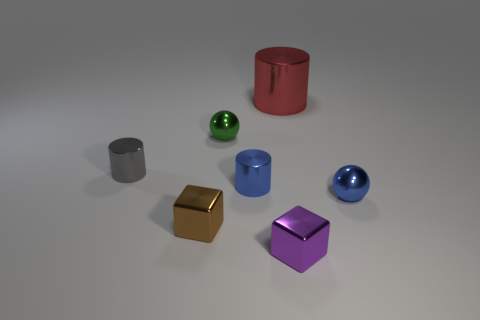Do the tiny cylinder on the right side of the small brown cube and the tiny ball to the right of the large metallic cylinder have the same color?
Ensure brevity in your answer.  Yes. What number of objects are either green shiny objects or tiny shiny blocks on the left side of the small purple shiny cube?
Ensure brevity in your answer.  2. What number of tiny gray cylinders are behind the sphere on the left side of the block that is to the right of the small green shiny sphere?
Your answer should be very brief. 0. Is there a purple block that has the same size as the gray cylinder?
Your answer should be compact. Yes. What is the color of the big shiny cylinder?
Give a very brief answer. Red. What color is the cylinder to the left of the tiny metal thing behind the small gray object?
Offer a terse response. Gray. There is a small blue thing right of the tiny blue metal thing that is on the left side of the small blue thing to the right of the tiny blue cylinder; what is its shape?
Your response must be concise. Sphere. How many tiny blue cylinders are the same material as the tiny purple thing?
Offer a very short reply. 1. How many small blocks are in front of the tiny blue thing that is on the right side of the small purple metallic cube?
Your answer should be compact. 2. What number of gray cylinders are there?
Your response must be concise. 1. 